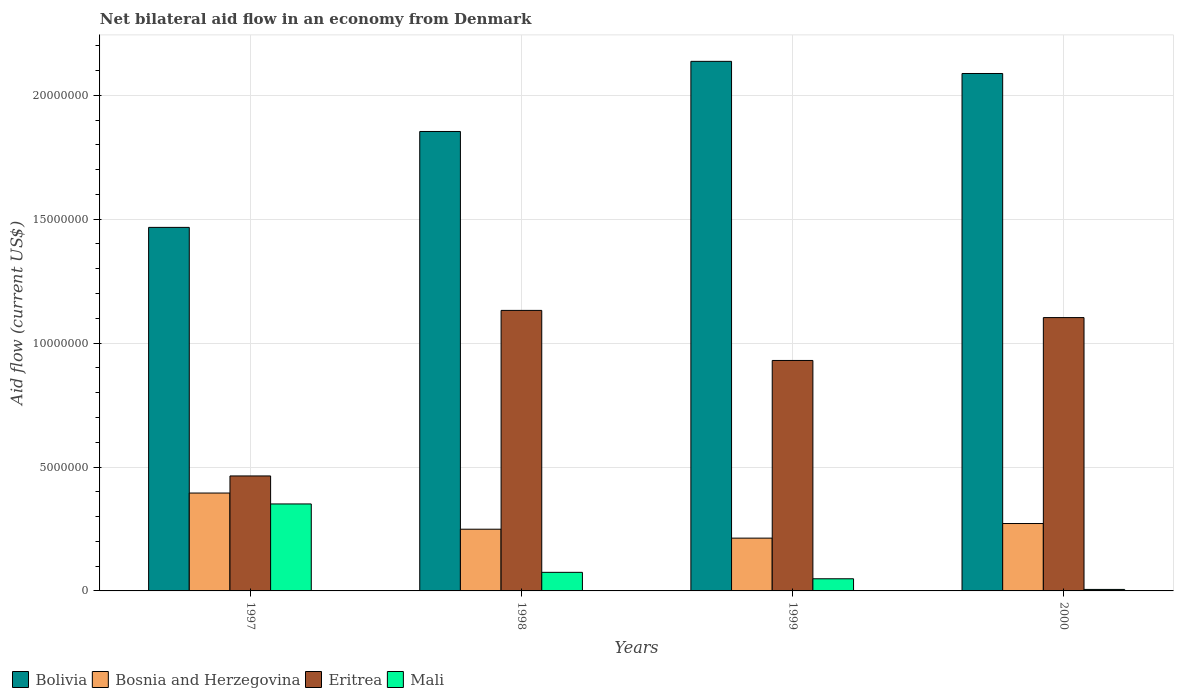How many groups of bars are there?
Your response must be concise. 4. Are the number of bars per tick equal to the number of legend labels?
Your answer should be compact. Yes. Are the number of bars on each tick of the X-axis equal?
Give a very brief answer. Yes. How many bars are there on the 4th tick from the left?
Your answer should be compact. 4. How many bars are there on the 1st tick from the right?
Make the answer very short. 4. What is the net bilateral aid flow in Bosnia and Herzegovina in 2000?
Provide a succinct answer. 2.72e+06. Across all years, what is the maximum net bilateral aid flow in Bolivia?
Provide a succinct answer. 2.14e+07. Across all years, what is the minimum net bilateral aid flow in Bolivia?
Offer a terse response. 1.47e+07. In which year was the net bilateral aid flow in Bolivia maximum?
Provide a succinct answer. 1999. What is the total net bilateral aid flow in Bosnia and Herzegovina in the graph?
Offer a very short reply. 1.13e+07. What is the difference between the net bilateral aid flow in Bolivia in 1997 and that in 1998?
Your response must be concise. -3.87e+06. What is the difference between the net bilateral aid flow in Eritrea in 2000 and the net bilateral aid flow in Bosnia and Herzegovina in 1998?
Make the answer very short. 8.54e+06. What is the average net bilateral aid flow in Eritrea per year?
Offer a terse response. 9.07e+06. In the year 2000, what is the difference between the net bilateral aid flow in Bosnia and Herzegovina and net bilateral aid flow in Mali?
Keep it short and to the point. 2.66e+06. What is the ratio of the net bilateral aid flow in Bosnia and Herzegovina in 1997 to that in 1999?
Provide a succinct answer. 1.85. Is the net bilateral aid flow in Mali in 1998 less than that in 1999?
Give a very brief answer. No. What is the difference between the highest and the second highest net bilateral aid flow in Bosnia and Herzegovina?
Provide a succinct answer. 1.23e+06. What is the difference between the highest and the lowest net bilateral aid flow in Bosnia and Herzegovina?
Offer a very short reply. 1.82e+06. In how many years, is the net bilateral aid flow in Bosnia and Herzegovina greater than the average net bilateral aid flow in Bosnia and Herzegovina taken over all years?
Give a very brief answer. 1. Is the sum of the net bilateral aid flow in Bolivia in 1997 and 2000 greater than the maximum net bilateral aid flow in Bosnia and Herzegovina across all years?
Ensure brevity in your answer.  Yes. Is it the case that in every year, the sum of the net bilateral aid flow in Mali and net bilateral aid flow in Eritrea is greater than the sum of net bilateral aid flow in Bolivia and net bilateral aid flow in Bosnia and Herzegovina?
Offer a very short reply. Yes. What does the 1st bar from the left in 2000 represents?
Give a very brief answer. Bolivia. What does the 3rd bar from the right in 1997 represents?
Keep it short and to the point. Bosnia and Herzegovina. How many bars are there?
Offer a very short reply. 16. How many years are there in the graph?
Provide a short and direct response. 4. What is the difference between two consecutive major ticks on the Y-axis?
Make the answer very short. 5.00e+06. Does the graph contain any zero values?
Provide a short and direct response. No. Does the graph contain grids?
Offer a terse response. Yes. Where does the legend appear in the graph?
Your answer should be compact. Bottom left. How many legend labels are there?
Provide a succinct answer. 4. How are the legend labels stacked?
Offer a very short reply. Horizontal. What is the title of the graph?
Your answer should be compact. Net bilateral aid flow in an economy from Denmark. What is the Aid flow (current US$) in Bolivia in 1997?
Make the answer very short. 1.47e+07. What is the Aid flow (current US$) in Bosnia and Herzegovina in 1997?
Your answer should be compact. 3.95e+06. What is the Aid flow (current US$) of Eritrea in 1997?
Ensure brevity in your answer.  4.64e+06. What is the Aid flow (current US$) of Mali in 1997?
Make the answer very short. 3.51e+06. What is the Aid flow (current US$) of Bolivia in 1998?
Make the answer very short. 1.85e+07. What is the Aid flow (current US$) of Bosnia and Herzegovina in 1998?
Provide a succinct answer. 2.49e+06. What is the Aid flow (current US$) of Eritrea in 1998?
Keep it short and to the point. 1.13e+07. What is the Aid flow (current US$) in Mali in 1998?
Your answer should be compact. 7.50e+05. What is the Aid flow (current US$) in Bolivia in 1999?
Offer a terse response. 2.14e+07. What is the Aid flow (current US$) in Bosnia and Herzegovina in 1999?
Keep it short and to the point. 2.13e+06. What is the Aid flow (current US$) in Eritrea in 1999?
Give a very brief answer. 9.30e+06. What is the Aid flow (current US$) of Bolivia in 2000?
Your answer should be very brief. 2.09e+07. What is the Aid flow (current US$) in Bosnia and Herzegovina in 2000?
Give a very brief answer. 2.72e+06. What is the Aid flow (current US$) in Eritrea in 2000?
Your answer should be compact. 1.10e+07. Across all years, what is the maximum Aid flow (current US$) of Bolivia?
Provide a short and direct response. 2.14e+07. Across all years, what is the maximum Aid flow (current US$) in Bosnia and Herzegovina?
Offer a terse response. 3.95e+06. Across all years, what is the maximum Aid flow (current US$) in Eritrea?
Make the answer very short. 1.13e+07. Across all years, what is the maximum Aid flow (current US$) of Mali?
Give a very brief answer. 3.51e+06. Across all years, what is the minimum Aid flow (current US$) of Bolivia?
Offer a very short reply. 1.47e+07. Across all years, what is the minimum Aid flow (current US$) in Bosnia and Herzegovina?
Give a very brief answer. 2.13e+06. Across all years, what is the minimum Aid flow (current US$) of Eritrea?
Your answer should be compact. 4.64e+06. Across all years, what is the minimum Aid flow (current US$) in Mali?
Ensure brevity in your answer.  6.00e+04. What is the total Aid flow (current US$) of Bolivia in the graph?
Give a very brief answer. 7.55e+07. What is the total Aid flow (current US$) in Bosnia and Herzegovina in the graph?
Give a very brief answer. 1.13e+07. What is the total Aid flow (current US$) in Eritrea in the graph?
Your response must be concise. 3.63e+07. What is the total Aid flow (current US$) of Mali in the graph?
Offer a terse response. 4.81e+06. What is the difference between the Aid flow (current US$) in Bolivia in 1997 and that in 1998?
Offer a very short reply. -3.87e+06. What is the difference between the Aid flow (current US$) of Bosnia and Herzegovina in 1997 and that in 1998?
Ensure brevity in your answer.  1.46e+06. What is the difference between the Aid flow (current US$) in Eritrea in 1997 and that in 1998?
Ensure brevity in your answer.  -6.68e+06. What is the difference between the Aid flow (current US$) of Mali in 1997 and that in 1998?
Your answer should be very brief. 2.76e+06. What is the difference between the Aid flow (current US$) in Bolivia in 1997 and that in 1999?
Ensure brevity in your answer.  -6.70e+06. What is the difference between the Aid flow (current US$) of Bosnia and Herzegovina in 1997 and that in 1999?
Provide a succinct answer. 1.82e+06. What is the difference between the Aid flow (current US$) in Eritrea in 1997 and that in 1999?
Provide a short and direct response. -4.66e+06. What is the difference between the Aid flow (current US$) in Mali in 1997 and that in 1999?
Provide a short and direct response. 3.02e+06. What is the difference between the Aid flow (current US$) in Bolivia in 1997 and that in 2000?
Ensure brevity in your answer.  -6.21e+06. What is the difference between the Aid flow (current US$) of Bosnia and Herzegovina in 1997 and that in 2000?
Your response must be concise. 1.23e+06. What is the difference between the Aid flow (current US$) of Eritrea in 1997 and that in 2000?
Offer a very short reply. -6.39e+06. What is the difference between the Aid flow (current US$) of Mali in 1997 and that in 2000?
Your answer should be compact. 3.45e+06. What is the difference between the Aid flow (current US$) in Bolivia in 1998 and that in 1999?
Offer a terse response. -2.83e+06. What is the difference between the Aid flow (current US$) in Bosnia and Herzegovina in 1998 and that in 1999?
Ensure brevity in your answer.  3.60e+05. What is the difference between the Aid flow (current US$) in Eritrea in 1998 and that in 1999?
Provide a short and direct response. 2.02e+06. What is the difference between the Aid flow (current US$) of Mali in 1998 and that in 1999?
Ensure brevity in your answer.  2.60e+05. What is the difference between the Aid flow (current US$) in Bolivia in 1998 and that in 2000?
Your answer should be very brief. -2.34e+06. What is the difference between the Aid flow (current US$) in Bosnia and Herzegovina in 1998 and that in 2000?
Provide a short and direct response. -2.30e+05. What is the difference between the Aid flow (current US$) in Eritrea in 1998 and that in 2000?
Make the answer very short. 2.90e+05. What is the difference between the Aid flow (current US$) in Mali in 1998 and that in 2000?
Your response must be concise. 6.90e+05. What is the difference between the Aid flow (current US$) of Bolivia in 1999 and that in 2000?
Provide a short and direct response. 4.90e+05. What is the difference between the Aid flow (current US$) of Bosnia and Herzegovina in 1999 and that in 2000?
Offer a terse response. -5.90e+05. What is the difference between the Aid flow (current US$) of Eritrea in 1999 and that in 2000?
Your response must be concise. -1.73e+06. What is the difference between the Aid flow (current US$) of Mali in 1999 and that in 2000?
Provide a short and direct response. 4.30e+05. What is the difference between the Aid flow (current US$) of Bolivia in 1997 and the Aid flow (current US$) of Bosnia and Herzegovina in 1998?
Provide a succinct answer. 1.22e+07. What is the difference between the Aid flow (current US$) of Bolivia in 1997 and the Aid flow (current US$) of Eritrea in 1998?
Your answer should be compact. 3.35e+06. What is the difference between the Aid flow (current US$) of Bolivia in 1997 and the Aid flow (current US$) of Mali in 1998?
Your answer should be very brief. 1.39e+07. What is the difference between the Aid flow (current US$) in Bosnia and Herzegovina in 1997 and the Aid flow (current US$) in Eritrea in 1998?
Provide a succinct answer. -7.37e+06. What is the difference between the Aid flow (current US$) of Bosnia and Herzegovina in 1997 and the Aid flow (current US$) of Mali in 1998?
Make the answer very short. 3.20e+06. What is the difference between the Aid flow (current US$) in Eritrea in 1997 and the Aid flow (current US$) in Mali in 1998?
Give a very brief answer. 3.89e+06. What is the difference between the Aid flow (current US$) of Bolivia in 1997 and the Aid flow (current US$) of Bosnia and Herzegovina in 1999?
Offer a terse response. 1.25e+07. What is the difference between the Aid flow (current US$) in Bolivia in 1997 and the Aid flow (current US$) in Eritrea in 1999?
Provide a succinct answer. 5.37e+06. What is the difference between the Aid flow (current US$) of Bolivia in 1997 and the Aid flow (current US$) of Mali in 1999?
Offer a terse response. 1.42e+07. What is the difference between the Aid flow (current US$) in Bosnia and Herzegovina in 1997 and the Aid flow (current US$) in Eritrea in 1999?
Make the answer very short. -5.35e+06. What is the difference between the Aid flow (current US$) of Bosnia and Herzegovina in 1997 and the Aid flow (current US$) of Mali in 1999?
Give a very brief answer. 3.46e+06. What is the difference between the Aid flow (current US$) of Eritrea in 1997 and the Aid flow (current US$) of Mali in 1999?
Ensure brevity in your answer.  4.15e+06. What is the difference between the Aid flow (current US$) of Bolivia in 1997 and the Aid flow (current US$) of Bosnia and Herzegovina in 2000?
Make the answer very short. 1.20e+07. What is the difference between the Aid flow (current US$) of Bolivia in 1997 and the Aid flow (current US$) of Eritrea in 2000?
Give a very brief answer. 3.64e+06. What is the difference between the Aid flow (current US$) in Bolivia in 1997 and the Aid flow (current US$) in Mali in 2000?
Ensure brevity in your answer.  1.46e+07. What is the difference between the Aid flow (current US$) in Bosnia and Herzegovina in 1997 and the Aid flow (current US$) in Eritrea in 2000?
Provide a succinct answer. -7.08e+06. What is the difference between the Aid flow (current US$) in Bosnia and Herzegovina in 1997 and the Aid flow (current US$) in Mali in 2000?
Give a very brief answer. 3.89e+06. What is the difference between the Aid flow (current US$) of Eritrea in 1997 and the Aid flow (current US$) of Mali in 2000?
Your answer should be very brief. 4.58e+06. What is the difference between the Aid flow (current US$) in Bolivia in 1998 and the Aid flow (current US$) in Bosnia and Herzegovina in 1999?
Make the answer very short. 1.64e+07. What is the difference between the Aid flow (current US$) of Bolivia in 1998 and the Aid flow (current US$) of Eritrea in 1999?
Make the answer very short. 9.24e+06. What is the difference between the Aid flow (current US$) in Bolivia in 1998 and the Aid flow (current US$) in Mali in 1999?
Your answer should be compact. 1.80e+07. What is the difference between the Aid flow (current US$) of Bosnia and Herzegovina in 1998 and the Aid flow (current US$) of Eritrea in 1999?
Ensure brevity in your answer.  -6.81e+06. What is the difference between the Aid flow (current US$) of Eritrea in 1998 and the Aid flow (current US$) of Mali in 1999?
Offer a very short reply. 1.08e+07. What is the difference between the Aid flow (current US$) in Bolivia in 1998 and the Aid flow (current US$) in Bosnia and Herzegovina in 2000?
Provide a short and direct response. 1.58e+07. What is the difference between the Aid flow (current US$) in Bolivia in 1998 and the Aid flow (current US$) in Eritrea in 2000?
Offer a terse response. 7.51e+06. What is the difference between the Aid flow (current US$) of Bolivia in 1998 and the Aid flow (current US$) of Mali in 2000?
Your response must be concise. 1.85e+07. What is the difference between the Aid flow (current US$) in Bosnia and Herzegovina in 1998 and the Aid flow (current US$) in Eritrea in 2000?
Ensure brevity in your answer.  -8.54e+06. What is the difference between the Aid flow (current US$) of Bosnia and Herzegovina in 1998 and the Aid flow (current US$) of Mali in 2000?
Keep it short and to the point. 2.43e+06. What is the difference between the Aid flow (current US$) in Eritrea in 1998 and the Aid flow (current US$) in Mali in 2000?
Provide a short and direct response. 1.13e+07. What is the difference between the Aid flow (current US$) of Bolivia in 1999 and the Aid flow (current US$) of Bosnia and Herzegovina in 2000?
Offer a terse response. 1.86e+07. What is the difference between the Aid flow (current US$) of Bolivia in 1999 and the Aid flow (current US$) of Eritrea in 2000?
Provide a succinct answer. 1.03e+07. What is the difference between the Aid flow (current US$) of Bolivia in 1999 and the Aid flow (current US$) of Mali in 2000?
Ensure brevity in your answer.  2.13e+07. What is the difference between the Aid flow (current US$) in Bosnia and Herzegovina in 1999 and the Aid flow (current US$) in Eritrea in 2000?
Keep it short and to the point. -8.90e+06. What is the difference between the Aid flow (current US$) of Bosnia and Herzegovina in 1999 and the Aid flow (current US$) of Mali in 2000?
Give a very brief answer. 2.07e+06. What is the difference between the Aid flow (current US$) in Eritrea in 1999 and the Aid flow (current US$) in Mali in 2000?
Ensure brevity in your answer.  9.24e+06. What is the average Aid flow (current US$) of Bolivia per year?
Offer a terse response. 1.89e+07. What is the average Aid flow (current US$) in Bosnia and Herzegovina per year?
Your response must be concise. 2.82e+06. What is the average Aid flow (current US$) of Eritrea per year?
Offer a terse response. 9.07e+06. What is the average Aid flow (current US$) of Mali per year?
Keep it short and to the point. 1.20e+06. In the year 1997, what is the difference between the Aid flow (current US$) in Bolivia and Aid flow (current US$) in Bosnia and Herzegovina?
Your response must be concise. 1.07e+07. In the year 1997, what is the difference between the Aid flow (current US$) in Bolivia and Aid flow (current US$) in Eritrea?
Your response must be concise. 1.00e+07. In the year 1997, what is the difference between the Aid flow (current US$) of Bolivia and Aid flow (current US$) of Mali?
Your response must be concise. 1.12e+07. In the year 1997, what is the difference between the Aid flow (current US$) in Bosnia and Herzegovina and Aid flow (current US$) in Eritrea?
Your answer should be very brief. -6.90e+05. In the year 1997, what is the difference between the Aid flow (current US$) in Eritrea and Aid flow (current US$) in Mali?
Offer a terse response. 1.13e+06. In the year 1998, what is the difference between the Aid flow (current US$) in Bolivia and Aid flow (current US$) in Bosnia and Herzegovina?
Give a very brief answer. 1.60e+07. In the year 1998, what is the difference between the Aid flow (current US$) of Bolivia and Aid flow (current US$) of Eritrea?
Make the answer very short. 7.22e+06. In the year 1998, what is the difference between the Aid flow (current US$) in Bolivia and Aid flow (current US$) in Mali?
Provide a succinct answer. 1.78e+07. In the year 1998, what is the difference between the Aid flow (current US$) of Bosnia and Herzegovina and Aid flow (current US$) of Eritrea?
Your response must be concise. -8.83e+06. In the year 1998, what is the difference between the Aid flow (current US$) in Bosnia and Herzegovina and Aid flow (current US$) in Mali?
Give a very brief answer. 1.74e+06. In the year 1998, what is the difference between the Aid flow (current US$) of Eritrea and Aid flow (current US$) of Mali?
Keep it short and to the point. 1.06e+07. In the year 1999, what is the difference between the Aid flow (current US$) in Bolivia and Aid flow (current US$) in Bosnia and Herzegovina?
Offer a very short reply. 1.92e+07. In the year 1999, what is the difference between the Aid flow (current US$) in Bolivia and Aid flow (current US$) in Eritrea?
Give a very brief answer. 1.21e+07. In the year 1999, what is the difference between the Aid flow (current US$) in Bolivia and Aid flow (current US$) in Mali?
Offer a terse response. 2.09e+07. In the year 1999, what is the difference between the Aid flow (current US$) in Bosnia and Herzegovina and Aid flow (current US$) in Eritrea?
Offer a very short reply. -7.17e+06. In the year 1999, what is the difference between the Aid flow (current US$) of Bosnia and Herzegovina and Aid flow (current US$) of Mali?
Ensure brevity in your answer.  1.64e+06. In the year 1999, what is the difference between the Aid flow (current US$) of Eritrea and Aid flow (current US$) of Mali?
Offer a very short reply. 8.81e+06. In the year 2000, what is the difference between the Aid flow (current US$) of Bolivia and Aid flow (current US$) of Bosnia and Herzegovina?
Your answer should be very brief. 1.82e+07. In the year 2000, what is the difference between the Aid flow (current US$) of Bolivia and Aid flow (current US$) of Eritrea?
Your answer should be compact. 9.85e+06. In the year 2000, what is the difference between the Aid flow (current US$) in Bolivia and Aid flow (current US$) in Mali?
Your response must be concise. 2.08e+07. In the year 2000, what is the difference between the Aid flow (current US$) in Bosnia and Herzegovina and Aid flow (current US$) in Eritrea?
Offer a very short reply. -8.31e+06. In the year 2000, what is the difference between the Aid flow (current US$) in Bosnia and Herzegovina and Aid flow (current US$) in Mali?
Your answer should be compact. 2.66e+06. In the year 2000, what is the difference between the Aid flow (current US$) in Eritrea and Aid flow (current US$) in Mali?
Give a very brief answer. 1.10e+07. What is the ratio of the Aid flow (current US$) in Bolivia in 1997 to that in 1998?
Your response must be concise. 0.79. What is the ratio of the Aid flow (current US$) of Bosnia and Herzegovina in 1997 to that in 1998?
Offer a terse response. 1.59. What is the ratio of the Aid flow (current US$) of Eritrea in 1997 to that in 1998?
Your answer should be compact. 0.41. What is the ratio of the Aid flow (current US$) in Mali in 1997 to that in 1998?
Ensure brevity in your answer.  4.68. What is the ratio of the Aid flow (current US$) in Bolivia in 1997 to that in 1999?
Give a very brief answer. 0.69. What is the ratio of the Aid flow (current US$) in Bosnia and Herzegovina in 1997 to that in 1999?
Ensure brevity in your answer.  1.85. What is the ratio of the Aid flow (current US$) in Eritrea in 1997 to that in 1999?
Offer a terse response. 0.5. What is the ratio of the Aid flow (current US$) in Mali in 1997 to that in 1999?
Keep it short and to the point. 7.16. What is the ratio of the Aid flow (current US$) in Bolivia in 1997 to that in 2000?
Give a very brief answer. 0.7. What is the ratio of the Aid flow (current US$) in Bosnia and Herzegovina in 1997 to that in 2000?
Your answer should be very brief. 1.45. What is the ratio of the Aid flow (current US$) of Eritrea in 1997 to that in 2000?
Your answer should be compact. 0.42. What is the ratio of the Aid flow (current US$) in Mali in 1997 to that in 2000?
Your answer should be very brief. 58.5. What is the ratio of the Aid flow (current US$) in Bolivia in 1998 to that in 1999?
Make the answer very short. 0.87. What is the ratio of the Aid flow (current US$) in Bosnia and Herzegovina in 1998 to that in 1999?
Ensure brevity in your answer.  1.17. What is the ratio of the Aid flow (current US$) in Eritrea in 1998 to that in 1999?
Your response must be concise. 1.22. What is the ratio of the Aid flow (current US$) of Mali in 1998 to that in 1999?
Your answer should be very brief. 1.53. What is the ratio of the Aid flow (current US$) of Bolivia in 1998 to that in 2000?
Make the answer very short. 0.89. What is the ratio of the Aid flow (current US$) of Bosnia and Herzegovina in 1998 to that in 2000?
Your answer should be compact. 0.92. What is the ratio of the Aid flow (current US$) of Eritrea in 1998 to that in 2000?
Offer a very short reply. 1.03. What is the ratio of the Aid flow (current US$) of Bolivia in 1999 to that in 2000?
Offer a terse response. 1.02. What is the ratio of the Aid flow (current US$) in Bosnia and Herzegovina in 1999 to that in 2000?
Your response must be concise. 0.78. What is the ratio of the Aid flow (current US$) in Eritrea in 1999 to that in 2000?
Offer a very short reply. 0.84. What is the ratio of the Aid flow (current US$) in Mali in 1999 to that in 2000?
Your answer should be very brief. 8.17. What is the difference between the highest and the second highest Aid flow (current US$) of Bolivia?
Keep it short and to the point. 4.90e+05. What is the difference between the highest and the second highest Aid flow (current US$) in Bosnia and Herzegovina?
Provide a succinct answer. 1.23e+06. What is the difference between the highest and the second highest Aid flow (current US$) of Mali?
Your answer should be compact. 2.76e+06. What is the difference between the highest and the lowest Aid flow (current US$) of Bolivia?
Your response must be concise. 6.70e+06. What is the difference between the highest and the lowest Aid flow (current US$) in Bosnia and Herzegovina?
Offer a terse response. 1.82e+06. What is the difference between the highest and the lowest Aid flow (current US$) in Eritrea?
Your answer should be very brief. 6.68e+06. What is the difference between the highest and the lowest Aid flow (current US$) of Mali?
Make the answer very short. 3.45e+06. 